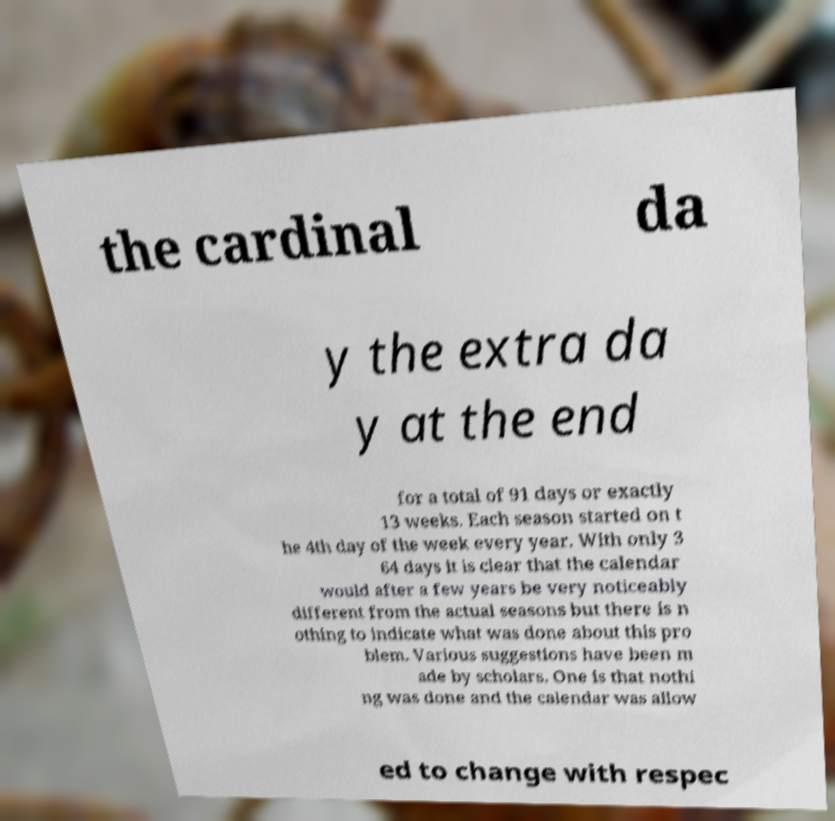For documentation purposes, I need the text within this image transcribed. Could you provide that? the cardinal da y the extra da y at the end for a total of 91 days or exactly 13 weeks. Each season started on t he 4th day of the week every year. With only 3 64 days it is clear that the calendar would after a few years be very noticeably different from the actual seasons but there is n othing to indicate what was done about this pro blem. Various suggestions have been m ade by scholars. One is that nothi ng was done and the calendar was allow ed to change with respec 